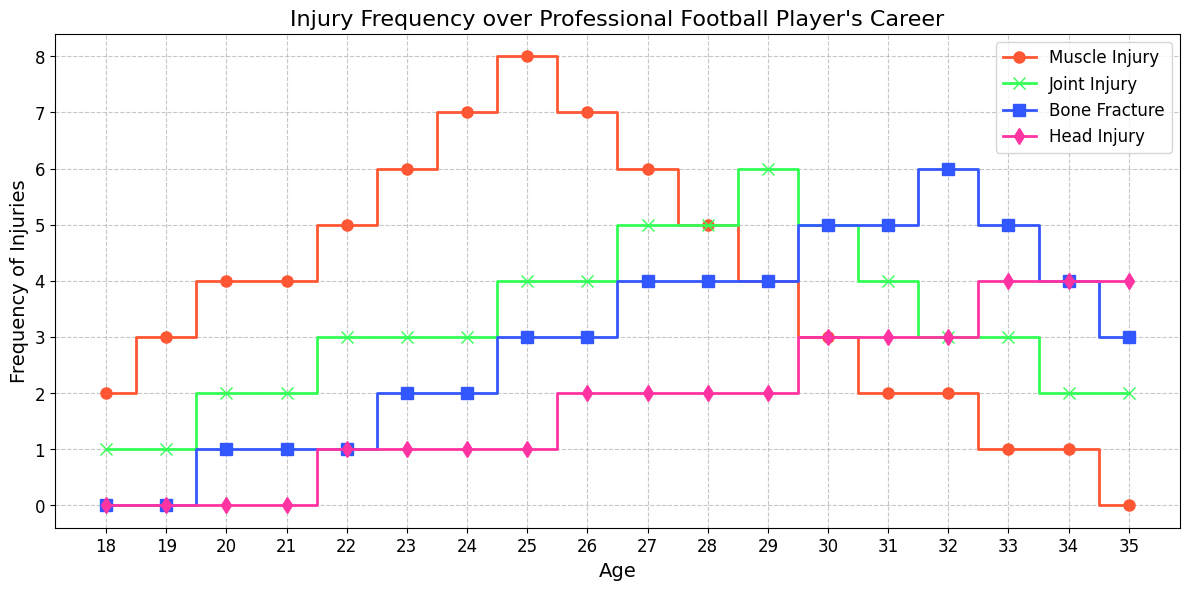What's the most frequent type of injury at age 26? At age 26, the number of muscle injuries is represented by the topmost line, joint injuries by the second line, bone fractures by the third line, and head injuries by the bottom line. The highest point at age 26 is for muscle injuries.
Answer: Muscle Injury At which age do head injuries first appear? Following the line corresponding to head injuries, the first point where it rises above zero is at age 22.
Answer: 22 Which injury type shows a decrease from age 25 to age 26? Observe the direction of each line from age 25 to 26. Only the muscle injury line shows a downward step from 8 to 7.
Answer: Muscle Injury What is the total number of muscle injuries from ages 18 to 22? The muscle injuries from ages 18 to 22 are 2, 3, 4, 4, and 5. Summing them gives 2 + 3 + 4 + 4 + 5 = 18.
Answer: 18 Between ages 30 and 35, which type of injury shows the most consistent number (does not increase or decrease much)? Analyze the lines between ages 30 and 35. The muscle injury line shows a consistent decrease, while the joint injuries line decreases but not consistently. The bone fracture line is quite stable, changing slowly, and the head injury line remains fairly stable. Bone fractures change slightly but not dramatically.
Answer: Bone Fracture At which age did joint injuries surpass muscle injuries? Follow the joint injuries line and the muscle injuries line. They intersect at age 29 where joint injuries move from 5 to 6, while muscle injuries move downwards.
Answer: 29 What is the average number of bone fractures between the ages of 24 and 34? Bone fractures between ages 24 and 34 are 2, 3, 3, 4, 4, 4, 4, 5, 5, 6, and 5. Summing them up gives 2 + 3 + 3 + 4 + 4 + 4 + 4 + 5 + 5 + 6 + 5 = 45. The number of ages is 11. So, the average is 45 / 11 ≈ 4.09.
Answer: 4.09 Which type of injury peaks the earliest in the player's career? By observing the points at which each line reaches its highest value, muscle injuries peak first around age 25.
Answer: Muscle Injury How many times do head injuries increase from age 18 to 35? Follow the head injury line from age 18 to 35. Head injuries increase from ages 21, 26, 27, 30, and finally 33. This gives us 5 increments.
Answer: 5 